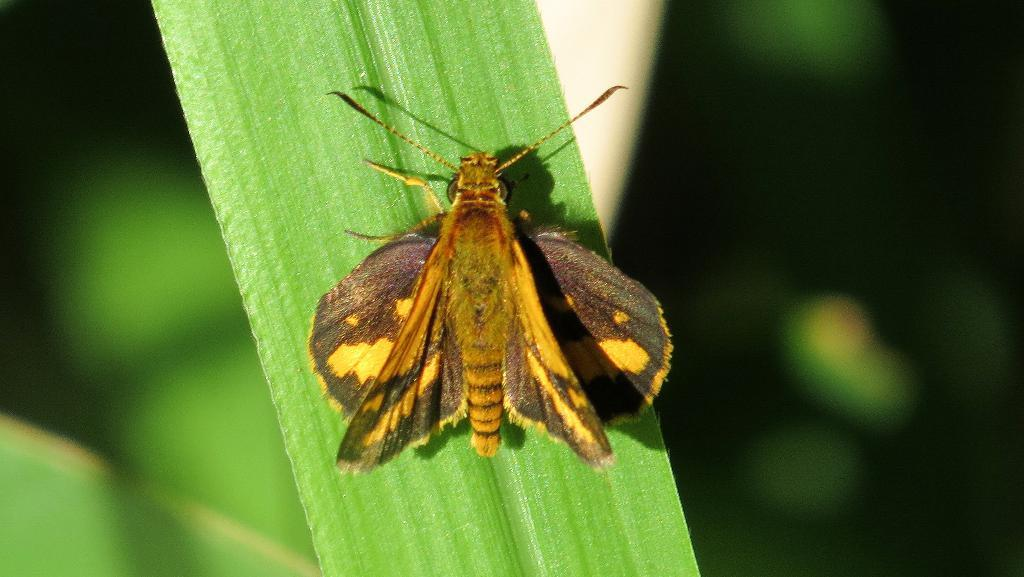What is the main subject of the image? There is a moth in the image. Where is the moth located in the image? The moth is standing on a leaf. What can be seen in the background of the image? There is a plant in the background of the image. What type of hammer is being used by the person in the image? There is no person or hammer present in the image; it features a moth standing on a leaf with a plant in the background. 